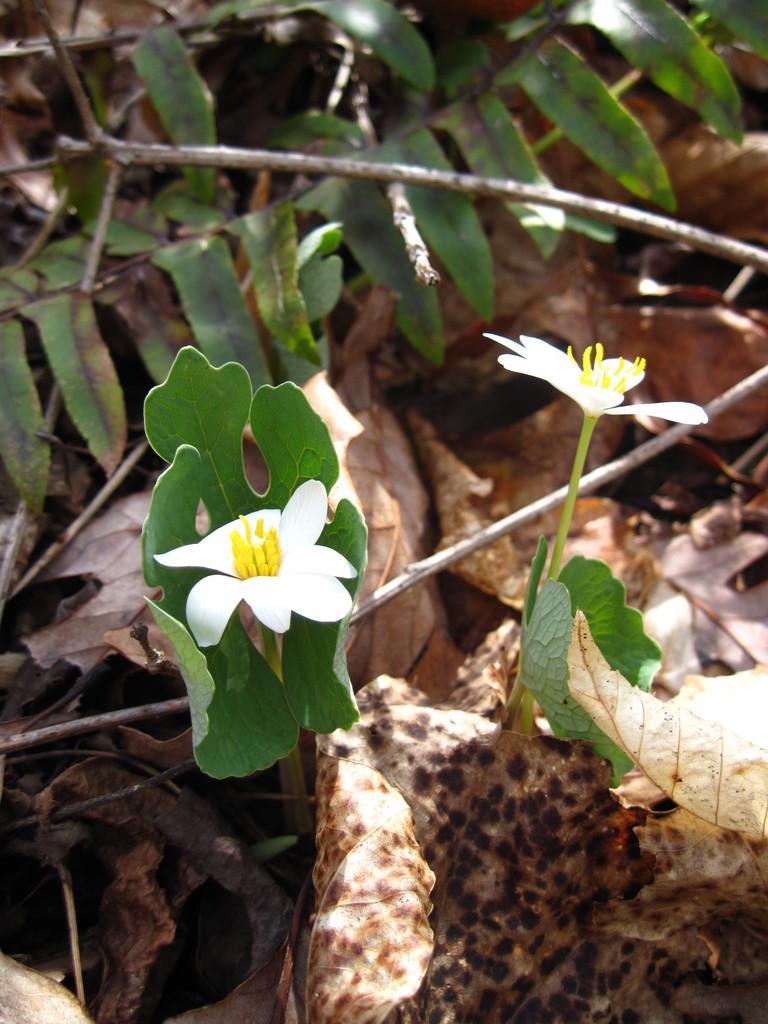In one or two sentences, can you explain what this image depicts? In this image, we can see some green color leaves and there are two white color flowers, we can see some dried leaves. 